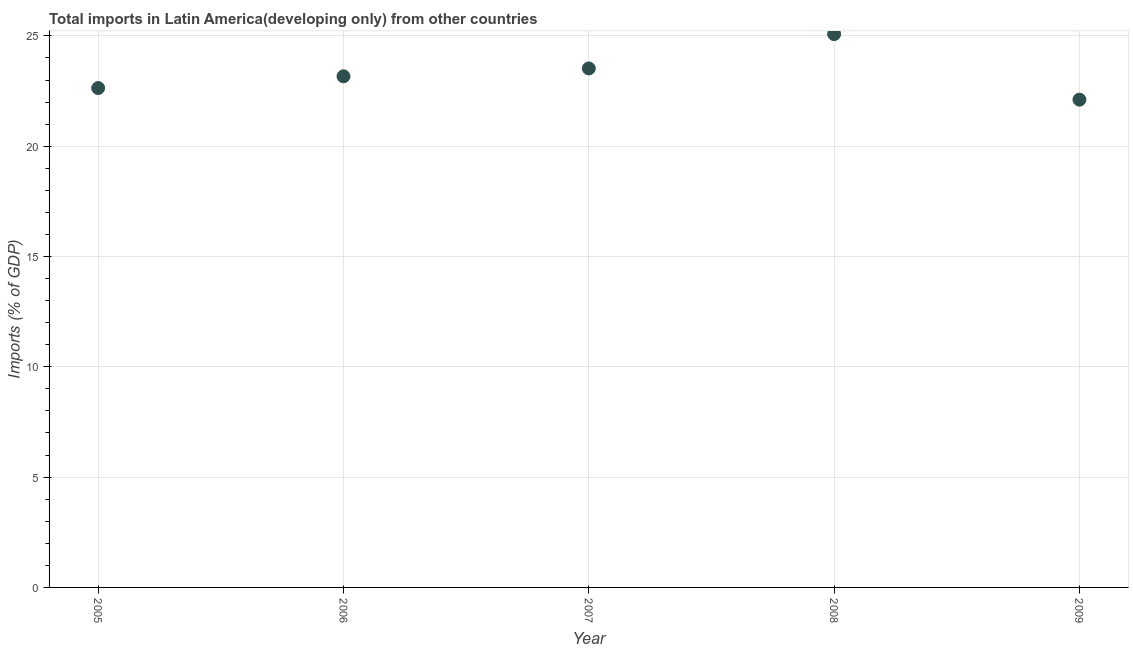What is the total imports in 2006?
Offer a terse response. 23.17. Across all years, what is the maximum total imports?
Provide a succinct answer. 25.08. Across all years, what is the minimum total imports?
Make the answer very short. 22.11. What is the sum of the total imports?
Provide a succinct answer. 116.52. What is the difference between the total imports in 2007 and 2009?
Your answer should be compact. 1.42. What is the average total imports per year?
Give a very brief answer. 23.3. What is the median total imports?
Your answer should be very brief. 23.17. What is the ratio of the total imports in 2006 to that in 2007?
Ensure brevity in your answer.  0.98. What is the difference between the highest and the second highest total imports?
Provide a short and direct response. 1.56. What is the difference between the highest and the lowest total imports?
Offer a very short reply. 2.97. In how many years, is the total imports greater than the average total imports taken over all years?
Offer a terse response. 2. Does the total imports monotonically increase over the years?
Provide a short and direct response. No. How many dotlines are there?
Make the answer very short. 1. How many years are there in the graph?
Your response must be concise. 5. What is the difference between two consecutive major ticks on the Y-axis?
Offer a very short reply. 5. What is the title of the graph?
Your answer should be compact. Total imports in Latin America(developing only) from other countries. What is the label or title of the Y-axis?
Make the answer very short. Imports (% of GDP). What is the Imports (% of GDP) in 2005?
Make the answer very short. 22.64. What is the Imports (% of GDP) in 2006?
Provide a succinct answer. 23.17. What is the Imports (% of GDP) in 2007?
Provide a short and direct response. 23.53. What is the Imports (% of GDP) in 2008?
Provide a succinct answer. 25.08. What is the Imports (% of GDP) in 2009?
Provide a short and direct response. 22.11. What is the difference between the Imports (% of GDP) in 2005 and 2006?
Provide a succinct answer. -0.53. What is the difference between the Imports (% of GDP) in 2005 and 2007?
Provide a short and direct response. -0.89. What is the difference between the Imports (% of GDP) in 2005 and 2008?
Your answer should be very brief. -2.45. What is the difference between the Imports (% of GDP) in 2005 and 2009?
Provide a short and direct response. 0.53. What is the difference between the Imports (% of GDP) in 2006 and 2007?
Give a very brief answer. -0.36. What is the difference between the Imports (% of GDP) in 2006 and 2008?
Provide a short and direct response. -1.91. What is the difference between the Imports (% of GDP) in 2006 and 2009?
Ensure brevity in your answer.  1.06. What is the difference between the Imports (% of GDP) in 2007 and 2008?
Provide a succinct answer. -1.56. What is the difference between the Imports (% of GDP) in 2007 and 2009?
Make the answer very short. 1.42. What is the difference between the Imports (% of GDP) in 2008 and 2009?
Ensure brevity in your answer.  2.97. What is the ratio of the Imports (% of GDP) in 2005 to that in 2006?
Your response must be concise. 0.98. What is the ratio of the Imports (% of GDP) in 2005 to that in 2007?
Make the answer very short. 0.96. What is the ratio of the Imports (% of GDP) in 2005 to that in 2008?
Give a very brief answer. 0.9. What is the ratio of the Imports (% of GDP) in 2006 to that in 2008?
Offer a terse response. 0.92. What is the ratio of the Imports (% of GDP) in 2006 to that in 2009?
Offer a terse response. 1.05. What is the ratio of the Imports (% of GDP) in 2007 to that in 2008?
Your answer should be very brief. 0.94. What is the ratio of the Imports (% of GDP) in 2007 to that in 2009?
Your answer should be compact. 1.06. What is the ratio of the Imports (% of GDP) in 2008 to that in 2009?
Provide a succinct answer. 1.13. 